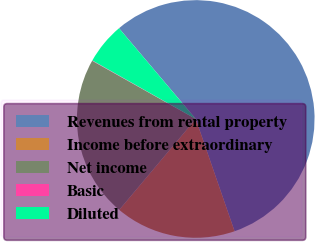Convert chart. <chart><loc_0><loc_0><loc_500><loc_500><pie_chart><fcel>Revenues from rental property<fcel>Income before extraordinary<fcel>Net income<fcel>Basic<fcel>Diluted<nl><fcel>55.87%<fcel>16.43%<fcel>22.01%<fcel>0.05%<fcel>5.63%<nl></chart> 